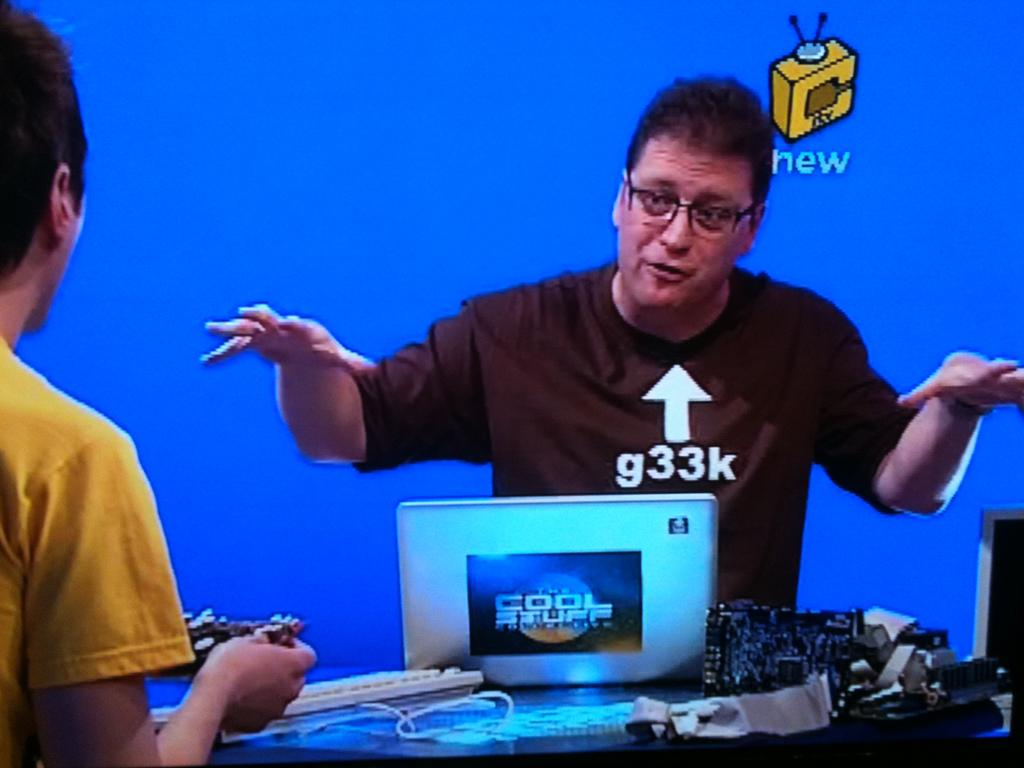<image>
Relay a brief, clear account of the picture shown. A man wearing a black tee shirt with the word new to his top right. 